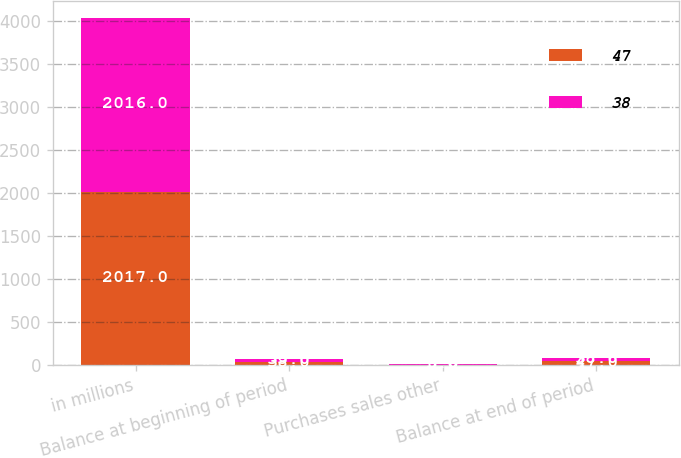Convert chart to OTSL. <chart><loc_0><loc_0><loc_500><loc_500><stacked_bar_chart><ecel><fcel>in millions<fcel>Balance at beginning of period<fcel>Purchases sales other<fcel>Balance at end of period<nl><fcel>47<fcel>2017<fcel>38<fcel>8<fcel>47<nl><fcel>38<fcel>2016<fcel>35<fcel>3<fcel>38<nl></chart> 